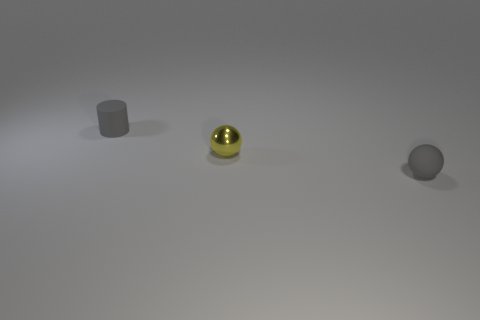Subtract all yellow balls. Subtract all cyan cylinders. How many balls are left? 1 Add 1 matte things. How many objects exist? 4 Subtract all spheres. How many objects are left? 1 Add 3 small gray rubber balls. How many small gray rubber balls are left? 4 Add 3 small brown blocks. How many small brown blocks exist? 3 Subtract 0 red cylinders. How many objects are left? 3 Subtract all green blocks. Subtract all small gray spheres. How many objects are left? 2 